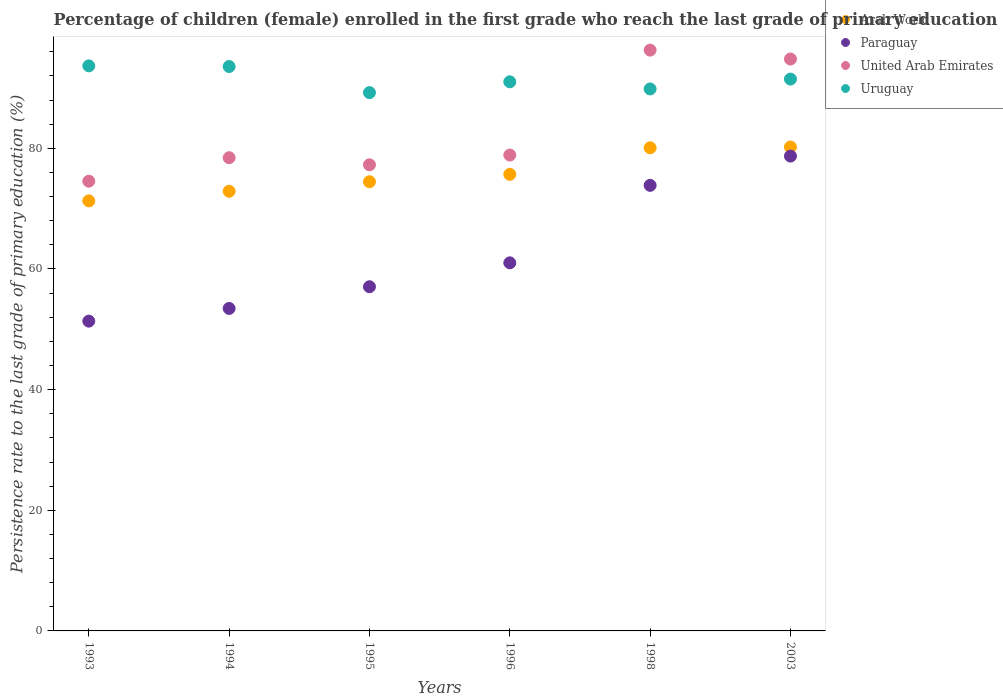How many different coloured dotlines are there?
Offer a terse response. 4. Is the number of dotlines equal to the number of legend labels?
Your answer should be very brief. Yes. What is the persistence rate of children in Uruguay in 2003?
Provide a short and direct response. 91.48. Across all years, what is the maximum persistence rate of children in United Arab Emirates?
Offer a very short reply. 96.27. Across all years, what is the minimum persistence rate of children in United Arab Emirates?
Your answer should be very brief. 74.54. In which year was the persistence rate of children in Arab World minimum?
Your answer should be very brief. 1993. What is the total persistence rate of children in Paraguay in the graph?
Provide a succinct answer. 375.43. What is the difference between the persistence rate of children in Paraguay in 1993 and that in 1995?
Offer a very short reply. -5.7. What is the difference between the persistence rate of children in United Arab Emirates in 1993 and the persistence rate of children in Paraguay in 1996?
Your response must be concise. 13.53. What is the average persistence rate of children in Paraguay per year?
Your answer should be compact. 62.57. In the year 2003, what is the difference between the persistence rate of children in Arab World and persistence rate of children in United Arab Emirates?
Make the answer very short. -14.58. In how many years, is the persistence rate of children in Uruguay greater than 32 %?
Offer a very short reply. 6. What is the ratio of the persistence rate of children in Paraguay in 1993 to that in 2003?
Provide a short and direct response. 0.65. Is the difference between the persistence rate of children in Arab World in 1993 and 1998 greater than the difference between the persistence rate of children in United Arab Emirates in 1993 and 1998?
Give a very brief answer. Yes. What is the difference between the highest and the second highest persistence rate of children in Paraguay?
Give a very brief answer. 4.85. What is the difference between the highest and the lowest persistence rate of children in Uruguay?
Offer a very short reply. 4.44. Is it the case that in every year, the sum of the persistence rate of children in Paraguay and persistence rate of children in Uruguay  is greater than the sum of persistence rate of children in United Arab Emirates and persistence rate of children in Arab World?
Keep it short and to the point. No. Is the persistence rate of children in United Arab Emirates strictly less than the persistence rate of children in Arab World over the years?
Your response must be concise. No. Does the graph contain any zero values?
Offer a very short reply. No. How many legend labels are there?
Your response must be concise. 4. How are the legend labels stacked?
Provide a short and direct response. Vertical. What is the title of the graph?
Your answer should be compact. Percentage of children (female) enrolled in the first grade who reach the last grade of primary education. Does "Seychelles" appear as one of the legend labels in the graph?
Your response must be concise. No. What is the label or title of the X-axis?
Your answer should be compact. Years. What is the label or title of the Y-axis?
Make the answer very short. Persistence rate to the last grade of primary education (%). What is the Persistence rate to the last grade of primary education (%) of Arab World in 1993?
Ensure brevity in your answer.  71.29. What is the Persistence rate to the last grade of primary education (%) in Paraguay in 1993?
Your response must be concise. 51.35. What is the Persistence rate to the last grade of primary education (%) of United Arab Emirates in 1993?
Ensure brevity in your answer.  74.54. What is the Persistence rate to the last grade of primary education (%) in Uruguay in 1993?
Your answer should be very brief. 93.66. What is the Persistence rate to the last grade of primary education (%) of Arab World in 1994?
Your answer should be very brief. 72.88. What is the Persistence rate to the last grade of primary education (%) in Paraguay in 1994?
Make the answer very short. 53.46. What is the Persistence rate to the last grade of primary education (%) of United Arab Emirates in 1994?
Your answer should be compact. 78.44. What is the Persistence rate to the last grade of primary education (%) in Uruguay in 1994?
Your answer should be compact. 93.55. What is the Persistence rate to the last grade of primary education (%) in Arab World in 1995?
Provide a succinct answer. 74.45. What is the Persistence rate to the last grade of primary education (%) in Paraguay in 1995?
Your answer should be very brief. 57.05. What is the Persistence rate to the last grade of primary education (%) in United Arab Emirates in 1995?
Your response must be concise. 77.26. What is the Persistence rate to the last grade of primary education (%) in Uruguay in 1995?
Offer a terse response. 89.23. What is the Persistence rate to the last grade of primary education (%) of Arab World in 1996?
Offer a terse response. 75.68. What is the Persistence rate to the last grade of primary education (%) in Paraguay in 1996?
Ensure brevity in your answer.  61.01. What is the Persistence rate to the last grade of primary education (%) in United Arab Emirates in 1996?
Your answer should be very brief. 78.88. What is the Persistence rate to the last grade of primary education (%) of Uruguay in 1996?
Offer a very short reply. 91.02. What is the Persistence rate to the last grade of primary education (%) in Arab World in 1998?
Your response must be concise. 80.08. What is the Persistence rate to the last grade of primary education (%) in Paraguay in 1998?
Your response must be concise. 73.86. What is the Persistence rate to the last grade of primary education (%) in United Arab Emirates in 1998?
Offer a terse response. 96.27. What is the Persistence rate to the last grade of primary education (%) of Uruguay in 1998?
Offer a terse response. 89.84. What is the Persistence rate to the last grade of primary education (%) of Arab World in 2003?
Your response must be concise. 80.22. What is the Persistence rate to the last grade of primary education (%) in Paraguay in 2003?
Provide a short and direct response. 78.71. What is the Persistence rate to the last grade of primary education (%) in United Arab Emirates in 2003?
Provide a succinct answer. 94.8. What is the Persistence rate to the last grade of primary education (%) of Uruguay in 2003?
Keep it short and to the point. 91.48. Across all years, what is the maximum Persistence rate to the last grade of primary education (%) of Arab World?
Your answer should be very brief. 80.22. Across all years, what is the maximum Persistence rate to the last grade of primary education (%) of Paraguay?
Keep it short and to the point. 78.71. Across all years, what is the maximum Persistence rate to the last grade of primary education (%) in United Arab Emirates?
Give a very brief answer. 96.27. Across all years, what is the maximum Persistence rate to the last grade of primary education (%) in Uruguay?
Offer a terse response. 93.66. Across all years, what is the minimum Persistence rate to the last grade of primary education (%) of Arab World?
Provide a short and direct response. 71.29. Across all years, what is the minimum Persistence rate to the last grade of primary education (%) in Paraguay?
Your response must be concise. 51.35. Across all years, what is the minimum Persistence rate to the last grade of primary education (%) of United Arab Emirates?
Offer a terse response. 74.54. Across all years, what is the minimum Persistence rate to the last grade of primary education (%) in Uruguay?
Keep it short and to the point. 89.23. What is the total Persistence rate to the last grade of primary education (%) in Arab World in the graph?
Keep it short and to the point. 454.61. What is the total Persistence rate to the last grade of primary education (%) of Paraguay in the graph?
Your response must be concise. 375.43. What is the total Persistence rate to the last grade of primary education (%) in United Arab Emirates in the graph?
Offer a terse response. 500.19. What is the total Persistence rate to the last grade of primary education (%) in Uruguay in the graph?
Your response must be concise. 548.78. What is the difference between the Persistence rate to the last grade of primary education (%) of Arab World in 1993 and that in 1994?
Your response must be concise. -1.59. What is the difference between the Persistence rate to the last grade of primary education (%) of Paraguay in 1993 and that in 1994?
Make the answer very short. -2.11. What is the difference between the Persistence rate to the last grade of primary education (%) in United Arab Emirates in 1993 and that in 1994?
Keep it short and to the point. -3.9. What is the difference between the Persistence rate to the last grade of primary education (%) in Uruguay in 1993 and that in 1994?
Offer a terse response. 0.11. What is the difference between the Persistence rate to the last grade of primary education (%) of Arab World in 1993 and that in 1995?
Make the answer very short. -3.17. What is the difference between the Persistence rate to the last grade of primary education (%) in Paraguay in 1993 and that in 1995?
Provide a short and direct response. -5.7. What is the difference between the Persistence rate to the last grade of primary education (%) in United Arab Emirates in 1993 and that in 1995?
Provide a succinct answer. -2.72. What is the difference between the Persistence rate to the last grade of primary education (%) of Uruguay in 1993 and that in 1995?
Offer a terse response. 4.44. What is the difference between the Persistence rate to the last grade of primary education (%) in Arab World in 1993 and that in 1996?
Your answer should be compact. -4.4. What is the difference between the Persistence rate to the last grade of primary education (%) in Paraguay in 1993 and that in 1996?
Keep it short and to the point. -9.66. What is the difference between the Persistence rate to the last grade of primary education (%) in United Arab Emirates in 1993 and that in 1996?
Provide a succinct answer. -4.33. What is the difference between the Persistence rate to the last grade of primary education (%) in Uruguay in 1993 and that in 1996?
Your answer should be compact. 2.64. What is the difference between the Persistence rate to the last grade of primary education (%) in Arab World in 1993 and that in 1998?
Provide a short and direct response. -8.8. What is the difference between the Persistence rate to the last grade of primary education (%) in Paraguay in 1993 and that in 1998?
Keep it short and to the point. -22.51. What is the difference between the Persistence rate to the last grade of primary education (%) of United Arab Emirates in 1993 and that in 1998?
Keep it short and to the point. -21.73. What is the difference between the Persistence rate to the last grade of primary education (%) of Uruguay in 1993 and that in 1998?
Your response must be concise. 3.82. What is the difference between the Persistence rate to the last grade of primary education (%) of Arab World in 1993 and that in 2003?
Offer a terse response. -8.93. What is the difference between the Persistence rate to the last grade of primary education (%) of Paraguay in 1993 and that in 2003?
Your answer should be compact. -27.36. What is the difference between the Persistence rate to the last grade of primary education (%) of United Arab Emirates in 1993 and that in 2003?
Keep it short and to the point. -20.25. What is the difference between the Persistence rate to the last grade of primary education (%) of Uruguay in 1993 and that in 2003?
Your answer should be compact. 2.19. What is the difference between the Persistence rate to the last grade of primary education (%) in Arab World in 1994 and that in 1995?
Give a very brief answer. -1.57. What is the difference between the Persistence rate to the last grade of primary education (%) in Paraguay in 1994 and that in 1995?
Keep it short and to the point. -3.59. What is the difference between the Persistence rate to the last grade of primary education (%) in United Arab Emirates in 1994 and that in 1995?
Provide a short and direct response. 1.18. What is the difference between the Persistence rate to the last grade of primary education (%) in Uruguay in 1994 and that in 1995?
Provide a short and direct response. 4.33. What is the difference between the Persistence rate to the last grade of primary education (%) of Arab World in 1994 and that in 1996?
Your answer should be compact. -2.8. What is the difference between the Persistence rate to the last grade of primary education (%) in Paraguay in 1994 and that in 1996?
Give a very brief answer. -7.56. What is the difference between the Persistence rate to the last grade of primary education (%) in United Arab Emirates in 1994 and that in 1996?
Keep it short and to the point. -0.44. What is the difference between the Persistence rate to the last grade of primary education (%) of Uruguay in 1994 and that in 1996?
Make the answer very short. 2.53. What is the difference between the Persistence rate to the last grade of primary education (%) of Arab World in 1994 and that in 1998?
Make the answer very short. -7.2. What is the difference between the Persistence rate to the last grade of primary education (%) in Paraguay in 1994 and that in 1998?
Offer a very short reply. -20.4. What is the difference between the Persistence rate to the last grade of primary education (%) in United Arab Emirates in 1994 and that in 1998?
Your answer should be compact. -17.83. What is the difference between the Persistence rate to the last grade of primary education (%) of Uruguay in 1994 and that in 1998?
Your answer should be very brief. 3.71. What is the difference between the Persistence rate to the last grade of primary education (%) of Arab World in 1994 and that in 2003?
Keep it short and to the point. -7.34. What is the difference between the Persistence rate to the last grade of primary education (%) in Paraguay in 1994 and that in 2003?
Give a very brief answer. -25.25. What is the difference between the Persistence rate to the last grade of primary education (%) in United Arab Emirates in 1994 and that in 2003?
Your answer should be compact. -16.36. What is the difference between the Persistence rate to the last grade of primary education (%) in Uruguay in 1994 and that in 2003?
Your response must be concise. 2.08. What is the difference between the Persistence rate to the last grade of primary education (%) in Arab World in 1995 and that in 1996?
Offer a very short reply. -1.23. What is the difference between the Persistence rate to the last grade of primary education (%) of Paraguay in 1995 and that in 1996?
Provide a succinct answer. -3.96. What is the difference between the Persistence rate to the last grade of primary education (%) of United Arab Emirates in 1995 and that in 1996?
Your response must be concise. -1.61. What is the difference between the Persistence rate to the last grade of primary education (%) in Uruguay in 1995 and that in 1996?
Give a very brief answer. -1.79. What is the difference between the Persistence rate to the last grade of primary education (%) in Arab World in 1995 and that in 1998?
Ensure brevity in your answer.  -5.63. What is the difference between the Persistence rate to the last grade of primary education (%) in Paraguay in 1995 and that in 1998?
Provide a succinct answer. -16.81. What is the difference between the Persistence rate to the last grade of primary education (%) in United Arab Emirates in 1995 and that in 1998?
Provide a succinct answer. -19.01. What is the difference between the Persistence rate to the last grade of primary education (%) in Uruguay in 1995 and that in 1998?
Offer a terse response. -0.61. What is the difference between the Persistence rate to the last grade of primary education (%) of Arab World in 1995 and that in 2003?
Your answer should be compact. -5.76. What is the difference between the Persistence rate to the last grade of primary education (%) of Paraguay in 1995 and that in 2003?
Keep it short and to the point. -21.66. What is the difference between the Persistence rate to the last grade of primary education (%) in United Arab Emirates in 1995 and that in 2003?
Offer a terse response. -17.53. What is the difference between the Persistence rate to the last grade of primary education (%) of Uruguay in 1995 and that in 2003?
Give a very brief answer. -2.25. What is the difference between the Persistence rate to the last grade of primary education (%) in Arab World in 1996 and that in 1998?
Keep it short and to the point. -4.4. What is the difference between the Persistence rate to the last grade of primary education (%) of Paraguay in 1996 and that in 1998?
Make the answer very short. -12.84. What is the difference between the Persistence rate to the last grade of primary education (%) in United Arab Emirates in 1996 and that in 1998?
Your response must be concise. -17.39. What is the difference between the Persistence rate to the last grade of primary education (%) in Uruguay in 1996 and that in 1998?
Offer a very short reply. 1.18. What is the difference between the Persistence rate to the last grade of primary education (%) of Arab World in 1996 and that in 2003?
Ensure brevity in your answer.  -4.53. What is the difference between the Persistence rate to the last grade of primary education (%) in Paraguay in 1996 and that in 2003?
Make the answer very short. -17.69. What is the difference between the Persistence rate to the last grade of primary education (%) in United Arab Emirates in 1996 and that in 2003?
Offer a very short reply. -15.92. What is the difference between the Persistence rate to the last grade of primary education (%) in Uruguay in 1996 and that in 2003?
Your answer should be very brief. -0.45. What is the difference between the Persistence rate to the last grade of primary education (%) in Arab World in 1998 and that in 2003?
Provide a short and direct response. -0.13. What is the difference between the Persistence rate to the last grade of primary education (%) of Paraguay in 1998 and that in 2003?
Ensure brevity in your answer.  -4.85. What is the difference between the Persistence rate to the last grade of primary education (%) in United Arab Emirates in 1998 and that in 2003?
Ensure brevity in your answer.  1.48. What is the difference between the Persistence rate to the last grade of primary education (%) of Uruguay in 1998 and that in 2003?
Give a very brief answer. -1.64. What is the difference between the Persistence rate to the last grade of primary education (%) in Arab World in 1993 and the Persistence rate to the last grade of primary education (%) in Paraguay in 1994?
Make the answer very short. 17.83. What is the difference between the Persistence rate to the last grade of primary education (%) of Arab World in 1993 and the Persistence rate to the last grade of primary education (%) of United Arab Emirates in 1994?
Your answer should be very brief. -7.15. What is the difference between the Persistence rate to the last grade of primary education (%) of Arab World in 1993 and the Persistence rate to the last grade of primary education (%) of Uruguay in 1994?
Your answer should be compact. -22.27. What is the difference between the Persistence rate to the last grade of primary education (%) in Paraguay in 1993 and the Persistence rate to the last grade of primary education (%) in United Arab Emirates in 1994?
Keep it short and to the point. -27.09. What is the difference between the Persistence rate to the last grade of primary education (%) of Paraguay in 1993 and the Persistence rate to the last grade of primary education (%) of Uruguay in 1994?
Your answer should be very brief. -42.21. What is the difference between the Persistence rate to the last grade of primary education (%) of United Arab Emirates in 1993 and the Persistence rate to the last grade of primary education (%) of Uruguay in 1994?
Provide a short and direct response. -19.01. What is the difference between the Persistence rate to the last grade of primary education (%) of Arab World in 1993 and the Persistence rate to the last grade of primary education (%) of Paraguay in 1995?
Give a very brief answer. 14.24. What is the difference between the Persistence rate to the last grade of primary education (%) in Arab World in 1993 and the Persistence rate to the last grade of primary education (%) in United Arab Emirates in 1995?
Your response must be concise. -5.98. What is the difference between the Persistence rate to the last grade of primary education (%) of Arab World in 1993 and the Persistence rate to the last grade of primary education (%) of Uruguay in 1995?
Offer a terse response. -17.94. What is the difference between the Persistence rate to the last grade of primary education (%) in Paraguay in 1993 and the Persistence rate to the last grade of primary education (%) in United Arab Emirates in 1995?
Your answer should be very brief. -25.91. What is the difference between the Persistence rate to the last grade of primary education (%) of Paraguay in 1993 and the Persistence rate to the last grade of primary education (%) of Uruguay in 1995?
Keep it short and to the point. -37.88. What is the difference between the Persistence rate to the last grade of primary education (%) of United Arab Emirates in 1993 and the Persistence rate to the last grade of primary education (%) of Uruguay in 1995?
Give a very brief answer. -14.68. What is the difference between the Persistence rate to the last grade of primary education (%) in Arab World in 1993 and the Persistence rate to the last grade of primary education (%) in Paraguay in 1996?
Offer a very short reply. 10.27. What is the difference between the Persistence rate to the last grade of primary education (%) of Arab World in 1993 and the Persistence rate to the last grade of primary education (%) of United Arab Emirates in 1996?
Keep it short and to the point. -7.59. What is the difference between the Persistence rate to the last grade of primary education (%) in Arab World in 1993 and the Persistence rate to the last grade of primary education (%) in Uruguay in 1996?
Provide a succinct answer. -19.73. What is the difference between the Persistence rate to the last grade of primary education (%) of Paraguay in 1993 and the Persistence rate to the last grade of primary education (%) of United Arab Emirates in 1996?
Provide a succinct answer. -27.53. What is the difference between the Persistence rate to the last grade of primary education (%) in Paraguay in 1993 and the Persistence rate to the last grade of primary education (%) in Uruguay in 1996?
Provide a succinct answer. -39.67. What is the difference between the Persistence rate to the last grade of primary education (%) in United Arab Emirates in 1993 and the Persistence rate to the last grade of primary education (%) in Uruguay in 1996?
Provide a succinct answer. -16.48. What is the difference between the Persistence rate to the last grade of primary education (%) in Arab World in 1993 and the Persistence rate to the last grade of primary education (%) in Paraguay in 1998?
Offer a very short reply. -2.57. What is the difference between the Persistence rate to the last grade of primary education (%) of Arab World in 1993 and the Persistence rate to the last grade of primary education (%) of United Arab Emirates in 1998?
Your answer should be compact. -24.98. What is the difference between the Persistence rate to the last grade of primary education (%) in Arab World in 1993 and the Persistence rate to the last grade of primary education (%) in Uruguay in 1998?
Give a very brief answer. -18.55. What is the difference between the Persistence rate to the last grade of primary education (%) in Paraguay in 1993 and the Persistence rate to the last grade of primary education (%) in United Arab Emirates in 1998?
Make the answer very short. -44.92. What is the difference between the Persistence rate to the last grade of primary education (%) of Paraguay in 1993 and the Persistence rate to the last grade of primary education (%) of Uruguay in 1998?
Offer a very short reply. -38.49. What is the difference between the Persistence rate to the last grade of primary education (%) in United Arab Emirates in 1993 and the Persistence rate to the last grade of primary education (%) in Uruguay in 1998?
Make the answer very short. -15.29. What is the difference between the Persistence rate to the last grade of primary education (%) in Arab World in 1993 and the Persistence rate to the last grade of primary education (%) in Paraguay in 2003?
Give a very brief answer. -7.42. What is the difference between the Persistence rate to the last grade of primary education (%) in Arab World in 1993 and the Persistence rate to the last grade of primary education (%) in United Arab Emirates in 2003?
Your response must be concise. -23.51. What is the difference between the Persistence rate to the last grade of primary education (%) of Arab World in 1993 and the Persistence rate to the last grade of primary education (%) of Uruguay in 2003?
Provide a short and direct response. -20.19. What is the difference between the Persistence rate to the last grade of primary education (%) in Paraguay in 1993 and the Persistence rate to the last grade of primary education (%) in United Arab Emirates in 2003?
Provide a short and direct response. -43.45. What is the difference between the Persistence rate to the last grade of primary education (%) in Paraguay in 1993 and the Persistence rate to the last grade of primary education (%) in Uruguay in 2003?
Give a very brief answer. -40.13. What is the difference between the Persistence rate to the last grade of primary education (%) of United Arab Emirates in 1993 and the Persistence rate to the last grade of primary education (%) of Uruguay in 2003?
Provide a short and direct response. -16.93. What is the difference between the Persistence rate to the last grade of primary education (%) in Arab World in 1994 and the Persistence rate to the last grade of primary education (%) in Paraguay in 1995?
Offer a very short reply. 15.83. What is the difference between the Persistence rate to the last grade of primary education (%) of Arab World in 1994 and the Persistence rate to the last grade of primary education (%) of United Arab Emirates in 1995?
Provide a succinct answer. -4.38. What is the difference between the Persistence rate to the last grade of primary education (%) in Arab World in 1994 and the Persistence rate to the last grade of primary education (%) in Uruguay in 1995?
Make the answer very short. -16.35. What is the difference between the Persistence rate to the last grade of primary education (%) of Paraguay in 1994 and the Persistence rate to the last grade of primary education (%) of United Arab Emirates in 1995?
Provide a succinct answer. -23.81. What is the difference between the Persistence rate to the last grade of primary education (%) of Paraguay in 1994 and the Persistence rate to the last grade of primary education (%) of Uruguay in 1995?
Keep it short and to the point. -35.77. What is the difference between the Persistence rate to the last grade of primary education (%) of United Arab Emirates in 1994 and the Persistence rate to the last grade of primary education (%) of Uruguay in 1995?
Ensure brevity in your answer.  -10.79. What is the difference between the Persistence rate to the last grade of primary education (%) in Arab World in 1994 and the Persistence rate to the last grade of primary education (%) in Paraguay in 1996?
Ensure brevity in your answer.  11.87. What is the difference between the Persistence rate to the last grade of primary education (%) in Arab World in 1994 and the Persistence rate to the last grade of primary education (%) in United Arab Emirates in 1996?
Provide a succinct answer. -6. What is the difference between the Persistence rate to the last grade of primary education (%) in Arab World in 1994 and the Persistence rate to the last grade of primary education (%) in Uruguay in 1996?
Provide a short and direct response. -18.14. What is the difference between the Persistence rate to the last grade of primary education (%) of Paraguay in 1994 and the Persistence rate to the last grade of primary education (%) of United Arab Emirates in 1996?
Offer a very short reply. -25.42. What is the difference between the Persistence rate to the last grade of primary education (%) of Paraguay in 1994 and the Persistence rate to the last grade of primary education (%) of Uruguay in 1996?
Your answer should be very brief. -37.57. What is the difference between the Persistence rate to the last grade of primary education (%) in United Arab Emirates in 1994 and the Persistence rate to the last grade of primary education (%) in Uruguay in 1996?
Ensure brevity in your answer.  -12.58. What is the difference between the Persistence rate to the last grade of primary education (%) of Arab World in 1994 and the Persistence rate to the last grade of primary education (%) of Paraguay in 1998?
Your answer should be compact. -0.97. What is the difference between the Persistence rate to the last grade of primary education (%) in Arab World in 1994 and the Persistence rate to the last grade of primary education (%) in United Arab Emirates in 1998?
Make the answer very short. -23.39. What is the difference between the Persistence rate to the last grade of primary education (%) of Arab World in 1994 and the Persistence rate to the last grade of primary education (%) of Uruguay in 1998?
Keep it short and to the point. -16.96. What is the difference between the Persistence rate to the last grade of primary education (%) in Paraguay in 1994 and the Persistence rate to the last grade of primary education (%) in United Arab Emirates in 1998?
Keep it short and to the point. -42.82. What is the difference between the Persistence rate to the last grade of primary education (%) of Paraguay in 1994 and the Persistence rate to the last grade of primary education (%) of Uruguay in 1998?
Provide a succinct answer. -36.38. What is the difference between the Persistence rate to the last grade of primary education (%) of United Arab Emirates in 1994 and the Persistence rate to the last grade of primary education (%) of Uruguay in 1998?
Your response must be concise. -11.4. What is the difference between the Persistence rate to the last grade of primary education (%) in Arab World in 1994 and the Persistence rate to the last grade of primary education (%) in Paraguay in 2003?
Your answer should be very brief. -5.83. What is the difference between the Persistence rate to the last grade of primary education (%) in Arab World in 1994 and the Persistence rate to the last grade of primary education (%) in United Arab Emirates in 2003?
Offer a terse response. -21.92. What is the difference between the Persistence rate to the last grade of primary education (%) in Arab World in 1994 and the Persistence rate to the last grade of primary education (%) in Uruguay in 2003?
Keep it short and to the point. -18.59. What is the difference between the Persistence rate to the last grade of primary education (%) of Paraguay in 1994 and the Persistence rate to the last grade of primary education (%) of United Arab Emirates in 2003?
Make the answer very short. -41.34. What is the difference between the Persistence rate to the last grade of primary education (%) of Paraguay in 1994 and the Persistence rate to the last grade of primary education (%) of Uruguay in 2003?
Ensure brevity in your answer.  -38.02. What is the difference between the Persistence rate to the last grade of primary education (%) in United Arab Emirates in 1994 and the Persistence rate to the last grade of primary education (%) in Uruguay in 2003?
Offer a very short reply. -13.04. What is the difference between the Persistence rate to the last grade of primary education (%) in Arab World in 1995 and the Persistence rate to the last grade of primary education (%) in Paraguay in 1996?
Offer a very short reply. 13.44. What is the difference between the Persistence rate to the last grade of primary education (%) in Arab World in 1995 and the Persistence rate to the last grade of primary education (%) in United Arab Emirates in 1996?
Your response must be concise. -4.42. What is the difference between the Persistence rate to the last grade of primary education (%) in Arab World in 1995 and the Persistence rate to the last grade of primary education (%) in Uruguay in 1996?
Ensure brevity in your answer.  -16.57. What is the difference between the Persistence rate to the last grade of primary education (%) in Paraguay in 1995 and the Persistence rate to the last grade of primary education (%) in United Arab Emirates in 1996?
Your response must be concise. -21.83. What is the difference between the Persistence rate to the last grade of primary education (%) of Paraguay in 1995 and the Persistence rate to the last grade of primary education (%) of Uruguay in 1996?
Offer a very short reply. -33.97. What is the difference between the Persistence rate to the last grade of primary education (%) of United Arab Emirates in 1995 and the Persistence rate to the last grade of primary education (%) of Uruguay in 1996?
Keep it short and to the point. -13.76. What is the difference between the Persistence rate to the last grade of primary education (%) of Arab World in 1995 and the Persistence rate to the last grade of primary education (%) of Paraguay in 1998?
Your answer should be very brief. 0.6. What is the difference between the Persistence rate to the last grade of primary education (%) of Arab World in 1995 and the Persistence rate to the last grade of primary education (%) of United Arab Emirates in 1998?
Provide a succinct answer. -21.82. What is the difference between the Persistence rate to the last grade of primary education (%) of Arab World in 1995 and the Persistence rate to the last grade of primary education (%) of Uruguay in 1998?
Make the answer very short. -15.38. What is the difference between the Persistence rate to the last grade of primary education (%) in Paraguay in 1995 and the Persistence rate to the last grade of primary education (%) in United Arab Emirates in 1998?
Your answer should be compact. -39.22. What is the difference between the Persistence rate to the last grade of primary education (%) of Paraguay in 1995 and the Persistence rate to the last grade of primary education (%) of Uruguay in 1998?
Your answer should be very brief. -32.79. What is the difference between the Persistence rate to the last grade of primary education (%) in United Arab Emirates in 1995 and the Persistence rate to the last grade of primary education (%) in Uruguay in 1998?
Make the answer very short. -12.58. What is the difference between the Persistence rate to the last grade of primary education (%) of Arab World in 1995 and the Persistence rate to the last grade of primary education (%) of Paraguay in 2003?
Ensure brevity in your answer.  -4.25. What is the difference between the Persistence rate to the last grade of primary education (%) of Arab World in 1995 and the Persistence rate to the last grade of primary education (%) of United Arab Emirates in 2003?
Your answer should be very brief. -20.34. What is the difference between the Persistence rate to the last grade of primary education (%) in Arab World in 1995 and the Persistence rate to the last grade of primary education (%) in Uruguay in 2003?
Make the answer very short. -17.02. What is the difference between the Persistence rate to the last grade of primary education (%) of Paraguay in 1995 and the Persistence rate to the last grade of primary education (%) of United Arab Emirates in 2003?
Make the answer very short. -37.75. What is the difference between the Persistence rate to the last grade of primary education (%) of Paraguay in 1995 and the Persistence rate to the last grade of primary education (%) of Uruguay in 2003?
Make the answer very short. -34.42. What is the difference between the Persistence rate to the last grade of primary education (%) in United Arab Emirates in 1995 and the Persistence rate to the last grade of primary education (%) in Uruguay in 2003?
Keep it short and to the point. -14.21. What is the difference between the Persistence rate to the last grade of primary education (%) in Arab World in 1996 and the Persistence rate to the last grade of primary education (%) in Paraguay in 1998?
Provide a succinct answer. 1.83. What is the difference between the Persistence rate to the last grade of primary education (%) of Arab World in 1996 and the Persistence rate to the last grade of primary education (%) of United Arab Emirates in 1998?
Give a very brief answer. -20.59. What is the difference between the Persistence rate to the last grade of primary education (%) of Arab World in 1996 and the Persistence rate to the last grade of primary education (%) of Uruguay in 1998?
Your answer should be very brief. -14.15. What is the difference between the Persistence rate to the last grade of primary education (%) of Paraguay in 1996 and the Persistence rate to the last grade of primary education (%) of United Arab Emirates in 1998?
Your response must be concise. -35.26. What is the difference between the Persistence rate to the last grade of primary education (%) in Paraguay in 1996 and the Persistence rate to the last grade of primary education (%) in Uruguay in 1998?
Offer a very short reply. -28.83. What is the difference between the Persistence rate to the last grade of primary education (%) in United Arab Emirates in 1996 and the Persistence rate to the last grade of primary education (%) in Uruguay in 1998?
Your answer should be compact. -10.96. What is the difference between the Persistence rate to the last grade of primary education (%) in Arab World in 1996 and the Persistence rate to the last grade of primary education (%) in Paraguay in 2003?
Your response must be concise. -3.02. What is the difference between the Persistence rate to the last grade of primary education (%) in Arab World in 1996 and the Persistence rate to the last grade of primary education (%) in United Arab Emirates in 2003?
Your answer should be compact. -19.11. What is the difference between the Persistence rate to the last grade of primary education (%) of Arab World in 1996 and the Persistence rate to the last grade of primary education (%) of Uruguay in 2003?
Ensure brevity in your answer.  -15.79. What is the difference between the Persistence rate to the last grade of primary education (%) of Paraguay in 1996 and the Persistence rate to the last grade of primary education (%) of United Arab Emirates in 2003?
Give a very brief answer. -33.78. What is the difference between the Persistence rate to the last grade of primary education (%) in Paraguay in 1996 and the Persistence rate to the last grade of primary education (%) in Uruguay in 2003?
Provide a short and direct response. -30.46. What is the difference between the Persistence rate to the last grade of primary education (%) of United Arab Emirates in 1996 and the Persistence rate to the last grade of primary education (%) of Uruguay in 2003?
Offer a terse response. -12.6. What is the difference between the Persistence rate to the last grade of primary education (%) in Arab World in 1998 and the Persistence rate to the last grade of primary education (%) in Paraguay in 2003?
Ensure brevity in your answer.  1.38. What is the difference between the Persistence rate to the last grade of primary education (%) of Arab World in 1998 and the Persistence rate to the last grade of primary education (%) of United Arab Emirates in 2003?
Your response must be concise. -14.71. What is the difference between the Persistence rate to the last grade of primary education (%) of Arab World in 1998 and the Persistence rate to the last grade of primary education (%) of Uruguay in 2003?
Make the answer very short. -11.39. What is the difference between the Persistence rate to the last grade of primary education (%) of Paraguay in 1998 and the Persistence rate to the last grade of primary education (%) of United Arab Emirates in 2003?
Offer a very short reply. -20.94. What is the difference between the Persistence rate to the last grade of primary education (%) in Paraguay in 1998 and the Persistence rate to the last grade of primary education (%) in Uruguay in 2003?
Provide a short and direct response. -17.62. What is the difference between the Persistence rate to the last grade of primary education (%) of United Arab Emirates in 1998 and the Persistence rate to the last grade of primary education (%) of Uruguay in 2003?
Offer a terse response. 4.8. What is the average Persistence rate to the last grade of primary education (%) of Arab World per year?
Make the answer very short. 75.77. What is the average Persistence rate to the last grade of primary education (%) in Paraguay per year?
Provide a short and direct response. 62.57. What is the average Persistence rate to the last grade of primary education (%) of United Arab Emirates per year?
Keep it short and to the point. 83.37. What is the average Persistence rate to the last grade of primary education (%) in Uruguay per year?
Offer a very short reply. 91.46. In the year 1993, what is the difference between the Persistence rate to the last grade of primary education (%) in Arab World and Persistence rate to the last grade of primary education (%) in Paraguay?
Provide a succinct answer. 19.94. In the year 1993, what is the difference between the Persistence rate to the last grade of primary education (%) in Arab World and Persistence rate to the last grade of primary education (%) in United Arab Emirates?
Ensure brevity in your answer.  -3.26. In the year 1993, what is the difference between the Persistence rate to the last grade of primary education (%) in Arab World and Persistence rate to the last grade of primary education (%) in Uruguay?
Your answer should be very brief. -22.38. In the year 1993, what is the difference between the Persistence rate to the last grade of primary education (%) in Paraguay and Persistence rate to the last grade of primary education (%) in United Arab Emirates?
Offer a very short reply. -23.2. In the year 1993, what is the difference between the Persistence rate to the last grade of primary education (%) of Paraguay and Persistence rate to the last grade of primary education (%) of Uruguay?
Your answer should be compact. -42.31. In the year 1993, what is the difference between the Persistence rate to the last grade of primary education (%) of United Arab Emirates and Persistence rate to the last grade of primary education (%) of Uruguay?
Make the answer very short. -19.12. In the year 1994, what is the difference between the Persistence rate to the last grade of primary education (%) in Arab World and Persistence rate to the last grade of primary education (%) in Paraguay?
Make the answer very short. 19.42. In the year 1994, what is the difference between the Persistence rate to the last grade of primary education (%) in Arab World and Persistence rate to the last grade of primary education (%) in United Arab Emirates?
Offer a terse response. -5.56. In the year 1994, what is the difference between the Persistence rate to the last grade of primary education (%) of Arab World and Persistence rate to the last grade of primary education (%) of Uruguay?
Give a very brief answer. -20.67. In the year 1994, what is the difference between the Persistence rate to the last grade of primary education (%) of Paraguay and Persistence rate to the last grade of primary education (%) of United Arab Emirates?
Offer a terse response. -24.98. In the year 1994, what is the difference between the Persistence rate to the last grade of primary education (%) in Paraguay and Persistence rate to the last grade of primary education (%) in Uruguay?
Your answer should be compact. -40.1. In the year 1994, what is the difference between the Persistence rate to the last grade of primary education (%) in United Arab Emirates and Persistence rate to the last grade of primary education (%) in Uruguay?
Offer a terse response. -15.11. In the year 1995, what is the difference between the Persistence rate to the last grade of primary education (%) of Arab World and Persistence rate to the last grade of primary education (%) of Paraguay?
Ensure brevity in your answer.  17.4. In the year 1995, what is the difference between the Persistence rate to the last grade of primary education (%) of Arab World and Persistence rate to the last grade of primary education (%) of United Arab Emirates?
Make the answer very short. -2.81. In the year 1995, what is the difference between the Persistence rate to the last grade of primary education (%) in Arab World and Persistence rate to the last grade of primary education (%) in Uruguay?
Your answer should be compact. -14.77. In the year 1995, what is the difference between the Persistence rate to the last grade of primary education (%) of Paraguay and Persistence rate to the last grade of primary education (%) of United Arab Emirates?
Give a very brief answer. -20.21. In the year 1995, what is the difference between the Persistence rate to the last grade of primary education (%) of Paraguay and Persistence rate to the last grade of primary education (%) of Uruguay?
Offer a very short reply. -32.18. In the year 1995, what is the difference between the Persistence rate to the last grade of primary education (%) of United Arab Emirates and Persistence rate to the last grade of primary education (%) of Uruguay?
Ensure brevity in your answer.  -11.96. In the year 1996, what is the difference between the Persistence rate to the last grade of primary education (%) of Arab World and Persistence rate to the last grade of primary education (%) of Paraguay?
Give a very brief answer. 14.67. In the year 1996, what is the difference between the Persistence rate to the last grade of primary education (%) of Arab World and Persistence rate to the last grade of primary education (%) of United Arab Emirates?
Your answer should be very brief. -3.19. In the year 1996, what is the difference between the Persistence rate to the last grade of primary education (%) of Arab World and Persistence rate to the last grade of primary education (%) of Uruguay?
Offer a very short reply. -15.34. In the year 1996, what is the difference between the Persistence rate to the last grade of primary education (%) of Paraguay and Persistence rate to the last grade of primary education (%) of United Arab Emirates?
Provide a short and direct response. -17.86. In the year 1996, what is the difference between the Persistence rate to the last grade of primary education (%) of Paraguay and Persistence rate to the last grade of primary education (%) of Uruguay?
Keep it short and to the point. -30.01. In the year 1996, what is the difference between the Persistence rate to the last grade of primary education (%) in United Arab Emirates and Persistence rate to the last grade of primary education (%) in Uruguay?
Ensure brevity in your answer.  -12.14. In the year 1998, what is the difference between the Persistence rate to the last grade of primary education (%) in Arab World and Persistence rate to the last grade of primary education (%) in Paraguay?
Provide a succinct answer. 6.23. In the year 1998, what is the difference between the Persistence rate to the last grade of primary education (%) in Arab World and Persistence rate to the last grade of primary education (%) in United Arab Emirates?
Your answer should be compact. -16.19. In the year 1998, what is the difference between the Persistence rate to the last grade of primary education (%) in Arab World and Persistence rate to the last grade of primary education (%) in Uruguay?
Keep it short and to the point. -9.76. In the year 1998, what is the difference between the Persistence rate to the last grade of primary education (%) in Paraguay and Persistence rate to the last grade of primary education (%) in United Arab Emirates?
Provide a short and direct response. -22.42. In the year 1998, what is the difference between the Persistence rate to the last grade of primary education (%) in Paraguay and Persistence rate to the last grade of primary education (%) in Uruguay?
Keep it short and to the point. -15.98. In the year 1998, what is the difference between the Persistence rate to the last grade of primary education (%) of United Arab Emirates and Persistence rate to the last grade of primary education (%) of Uruguay?
Offer a very short reply. 6.43. In the year 2003, what is the difference between the Persistence rate to the last grade of primary education (%) of Arab World and Persistence rate to the last grade of primary education (%) of Paraguay?
Your answer should be compact. 1.51. In the year 2003, what is the difference between the Persistence rate to the last grade of primary education (%) of Arab World and Persistence rate to the last grade of primary education (%) of United Arab Emirates?
Offer a very short reply. -14.58. In the year 2003, what is the difference between the Persistence rate to the last grade of primary education (%) in Arab World and Persistence rate to the last grade of primary education (%) in Uruguay?
Keep it short and to the point. -11.26. In the year 2003, what is the difference between the Persistence rate to the last grade of primary education (%) in Paraguay and Persistence rate to the last grade of primary education (%) in United Arab Emirates?
Make the answer very short. -16.09. In the year 2003, what is the difference between the Persistence rate to the last grade of primary education (%) of Paraguay and Persistence rate to the last grade of primary education (%) of Uruguay?
Offer a terse response. -12.77. In the year 2003, what is the difference between the Persistence rate to the last grade of primary education (%) in United Arab Emirates and Persistence rate to the last grade of primary education (%) in Uruguay?
Offer a terse response. 3.32. What is the ratio of the Persistence rate to the last grade of primary education (%) in Arab World in 1993 to that in 1994?
Your answer should be very brief. 0.98. What is the ratio of the Persistence rate to the last grade of primary education (%) in Paraguay in 1993 to that in 1994?
Ensure brevity in your answer.  0.96. What is the ratio of the Persistence rate to the last grade of primary education (%) of United Arab Emirates in 1993 to that in 1994?
Provide a succinct answer. 0.95. What is the ratio of the Persistence rate to the last grade of primary education (%) in Uruguay in 1993 to that in 1994?
Keep it short and to the point. 1. What is the ratio of the Persistence rate to the last grade of primary education (%) of Arab World in 1993 to that in 1995?
Your answer should be compact. 0.96. What is the ratio of the Persistence rate to the last grade of primary education (%) in Paraguay in 1993 to that in 1995?
Your response must be concise. 0.9. What is the ratio of the Persistence rate to the last grade of primary education (%) of United Arab Emirates in 1993 to that in 1995?
Keep it short and to the point. 0.96. What is the ratio of the Persistence rate to the last grade of primary education (%) of Uruguay in 1993 to that in 1995?
Offer a terse response. 1.05. What is the ratio of the Persistence rate to the last grade of primary education (%) in Arab World in 1993 to that in 1996?
Your answer should be very brief. 0.94. What is the ratio of the Persistence rate to the last grade of primary education (%) in Paraguay in 1993 to that in 1996?
Your answer should be compact. 0.84. What is the ratio of the Persistence rate to the last grade of primary education (%) in United Arab Emirates in 1993 to that in 1996?
Your response must be concise. 0.95. What is the ratio of the Persistence rate to the last grade of primary education (%) in Uruguay in 1993 to that in 1996?
Ensure brevity in your answer.  1.03. What is the ratio of the Persistence rate to the last grade of primary education (%) of Arab World in 1993 to that in 1998?
Provide a short and direct response. 0.89. What is the ratio of the Persistence rate to the last grade of primary education (%) in Paraguay in 1993 to that in 1998?
Your response must be concise. 0.7. What is the ratio of the Persistence rate to the last grade of primary education (%) of United Arab Emirates in 1993 to that in 1998?
Your response must be concise. 0.77. What is the ratio of the Persistence rate to the last grade of primary education (%) of Uruguay in 1993 to that in 1998?
Give a very brief answer. 1.04. What is the ratio of the Persistence rate to the last grade of primary education (%) in Arab World in 1993 to that in 2003?
Ensure brevity in your answer.  0.89. What is the ratio of the Persistence rate to the last grade of primary education (%) of Paraguay in 1993 to that in 2003?
Keep it short and to the point. 0.65. What is the ratio of the Persistence rate to the last grade of primary education (%) in United Arab Emirates in 1993 to that in 2003?
Provide a succinct answer. 0.79. What is the ratio of the Persistence rate to the last grade of primary education (%) in Uruguay in 1993 to that in 2003?
Provide a succinct answer. 1.02. What is the ratio of the Persistence rate to the last grade of primary education (%) of Arab World in 1994 to that in 1995?
Your answer should be very brief. 0.98. What is the ratio of the Persistence rate to the last grade of primary education (%) in Paraguay in 1994 to that in 1995?
Your response must be concise. 0.94. What is the ratio of the Persistence rate to the last grade of primary education (%) of United Arab Emirates in 1994 to that in 1995?
Your answer should be very brief. 1.02. What is the ratio of the Persistence rate to the last grade of primary education (%) of Uruguay in 1994 to that in 1995?
Keep it short and to the point. 1.05. What is the ratio of the Persistence rate to the last grade of primary education (%) in Arab World in 1994 to that in 1996?
Offer a very short reply. 0.96. What is the ratio of the Persistence rate to the last grade of primary education (%) in Paraguay in 1994 to that in 1996?
Your response must be concise. 0.88. What is the ratio of the Persistence rate to the last grade of primary education (%) of Uruguay in 1994 to that in 1996?
Your answer should be very brief. 1.03. What is the ratio of the Persistence rate to the last grade of primary education (%) in Arab World in 1994 to that in 1998?
Make the answer very short. 0.91. What is the ratio of the Persistence rate to the last grade of primary education (%) in Paraguay in 1994 to that in 1998?
Give a very brief answer. 0.72. What is the ratio of the Persistence rate to the last grade of primary education (%) in United Arab Emirates in 1994 to that in 1998?
Give a very brief answer. 0.81. What is the ratio of the Persistence rate to the last grade of primary education (%) of Uruguay in 1994 to that in 1998?
Ensure brevity in your answer.  1.04. What is the ratio of the Persistence rate to the last grade of primary education (%) in Arab World in 1994 to that in 2003?
Provide a succinct answer. 0.91. What is the ratio of the Persistence rate to the last grade of primary education (%) in Paraguay in 1994 to that in 2003?
Make the answer very short. 0.68. What is the ratio of the Persistence rate to the last grade of primary education (%) of United Arab Emirates in 1994 to that in 2003?
Ensure brevity in your answer.  0.83. What is the ratio of the Persistence rate to the last grade of primary education (%) of Uruguay in 1994 to that in 2003?
Keep it short and to the point. 1.02. What is the ratio of the Persistence rate to the last grade of primary education (%) in Arab World in 1995 to that in 1996?
Your response must be concise. 0.98. What is the ratio of the Persistence rate to the last grade of primary education (%) of Paraguay in 1995 to that in 1996?
Your answer should be compact. 0.94. What is the ratio of the Persistence rate to the last grade of primary education (%) in United Arab Emirates in 1995 to that in 1996?
Ensure brevity in your answer.  0.98. What is the ratio of the Persistence rate to the last grade of primary education (%) of Uruguay in 1995 to that in 1996?
Give a very brief answer. 0.98. What is the ratio of the Persistence rate to the last grade of primary education (%) of Arab World in 1995 to that in 1998?
Provide a short and direct response. 0.93. What is the ratio of the Persistence rate to the last grade of primary education (%) in Paraguay in 1995 to that in 1998?
Provide a succinct answer. 0.77. What is the ratio of the Persistence rate to the last grade of primary education (%) in United Arab Emirates in 1995 to that in 1998?
Offer a very short reply. 0.8. What is the ratio of the Persistence rate to the last grade of primary education (%) of Arab World in 1995 to that in 2003?
Ensure brevity in your answer.  0.93. What is the ratio of the Persistence rate to the last grade of primary education (%) in Paraguay in 1995 to that in 2003?
Offer a terse response. 0.72. What is the ratio of the Persistence rate to the last grade of primary education (%) in United Arab Emirates in 1995 to that in 2003?
Keep it short and to the point. 0.82. What is the ratio of the Persistence rate to the last grade of primary education (%) of Uruguay in 1995 to that in 2003?
Your response must be concise. 0.98. What is the ratio of the Persistence rate to the last grade of primary education (%) in Arab World in 1996 to that in 1998?
Your answer should be compact. 0.95. What is the ratio of the Persistence rate to the last grade of primary education (%) in Paraguay in 1996 to that in 1998?
Provide a succinct answer. 0.83. What is the ratio of the Persistence rate to the last grade of primary education (%) in United Arab Emirates in 1996 to that in 1998?
Offer a very short reply. 0.82. What is the ratio of the Persistence rate to the last grade of primary education (%) in Uruguay in 1996 to that in 1998?
Give a very brief answer. 1.01. What is the ratio of the Persistence rate to the last grade of primary education (%) of Arab World in 1996 to that in 2003?
Your answer should be very brief. 0.94. What is the ratio of the Persistence rate to the last grade of primary education (%) of Paraguay in 1996 to that in 2003?
Offer a very short reply. 0.78. What is the ratio of the Persistence rate to the last grade of primary education (%) in United Arab Emirates in 1996 to that in 2003?
Make the answer very short. 0.83. What is the ratio of the Persistence rate to the last grade of primary education (%) in Uruguay in 1996 to that in 2003?
Your response must be concise. 0.99. What is the ratio of the Persistence rate to the last grade of primary education (%) of Paraguay in 1998 to that in 2003?
Keep it short and to the point. 0.94. What is the ratio of the Persistence rate to the last grade of primary education (%) in United Arab Emirates in 1998 to that in 2003?
Make the answer very short. 1.02. What is the ratio of the Persistence rate to the last grade of primary education (%) of Uruguay in 1998 to that in 2003?
Your answer should be very brief. 0.98. What is the difference between the highest and the second highest Persistence rate to the last grade of primary education (%) in Arab World?
Keep it short and to the point. 0.13. What is the difference between the highest and the second highest Persistence rate to the last grade of primary education (%) in Paraguay?
Make the answer very short. 4.85. What is the difference between the highest and the second highest Persistence rate to the last grade of primary education (%) of United Arab Emirates?
Your response must be concise. 1.48. What is the difference between the highest and the second highest Persistence rate to the last grade of primary education (%) in Uruguay?
Offer a very short reply. 0.11. What is the difference between the highest and the lowest Persistence rate to the last grade of primary education (%) of Arab World?
Provide a succinct answer. 8.93. What is the difference between the highest and the lowest Persistence rate to the last grade of primary education (%) of Paraguay?
Provide a short and direct response. 27.36. What is the difference between the highest and the lowest Persistence rate to the last grade of primary education (%) in United Arab Emirates?
Your answer should be compact. 21.73. What is the difference between the highest and the lowest Persistence rate to the last grade of primary education (%) in Uruguay?
Give a very brief answer. 4.44. 